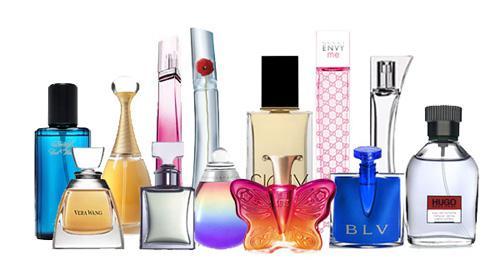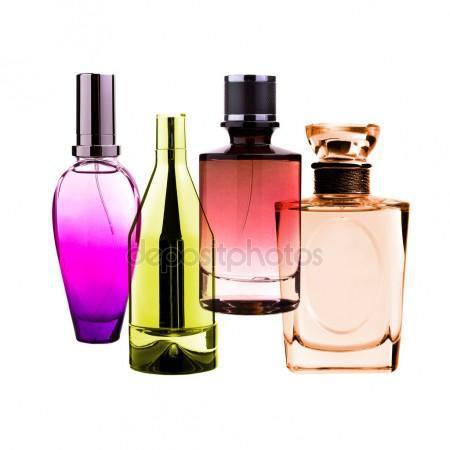The first image is the image on the left, the second image is the image on the right. For the images displayed, is the sentence "There is a single vial near its box in one of the images." factually correct? Answer yes or no. No. 